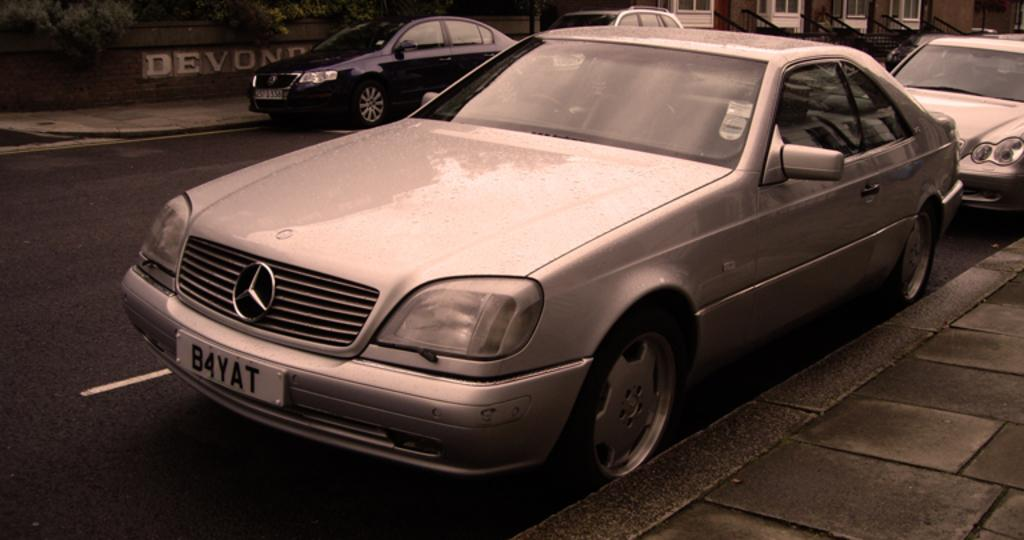<image>
Offer a succinct explanation of the picture presented. Silver Mercedes park on the street side in front of the Devond wall. 